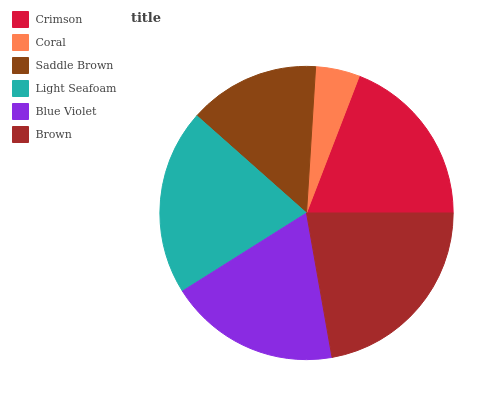Is Coral the minimum?
Answer yes or no. Yes. Is Brown the maximum?
Answer yes or no. Yes. Is Saddle Brown the minimum?
Answer yes or no. No. Is Saddle Brown the maximum?
Answer yes or no. No. Is Saddle Brown greater than Coral?
Answer yes or no. Yes. Is Coral less than Saddle Brown?
Answer yes or no. Yes. Is Coral greater than Saddle Brown?
Answer yes or no. No. Is Saddle Brown less than Coral?
Answer yes or no. No. Is Crimson the high median?
Answer yes or no. Yes. Is Blue Violet the low median?
Answer yes or no. Yes. Is Saddle Brown the high median?
Answer yes or no. No. Is Coral the low median?
Answer yes or no. No. 